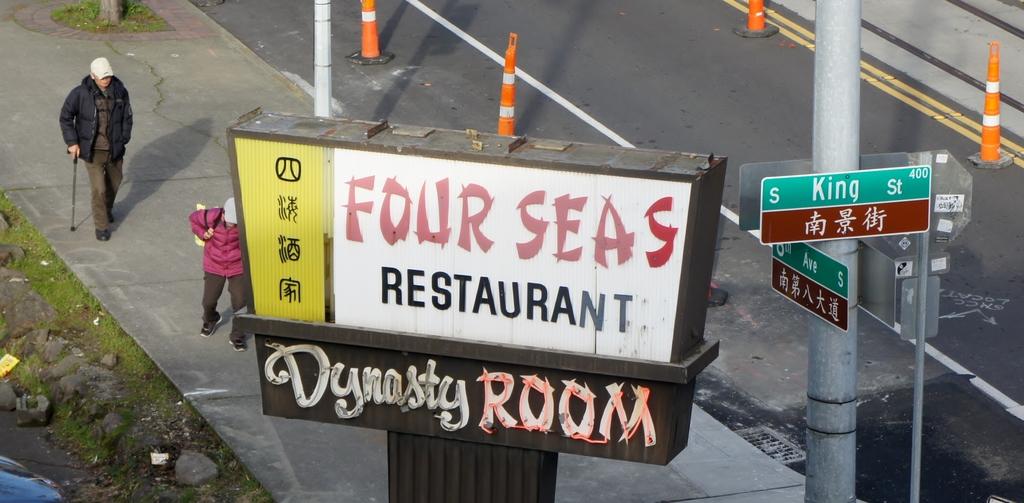What is the restaraunt called?
Make the answer very short. Four seas. What is the name of the street next to the four seas sign?
Offer a very short reply. King. 